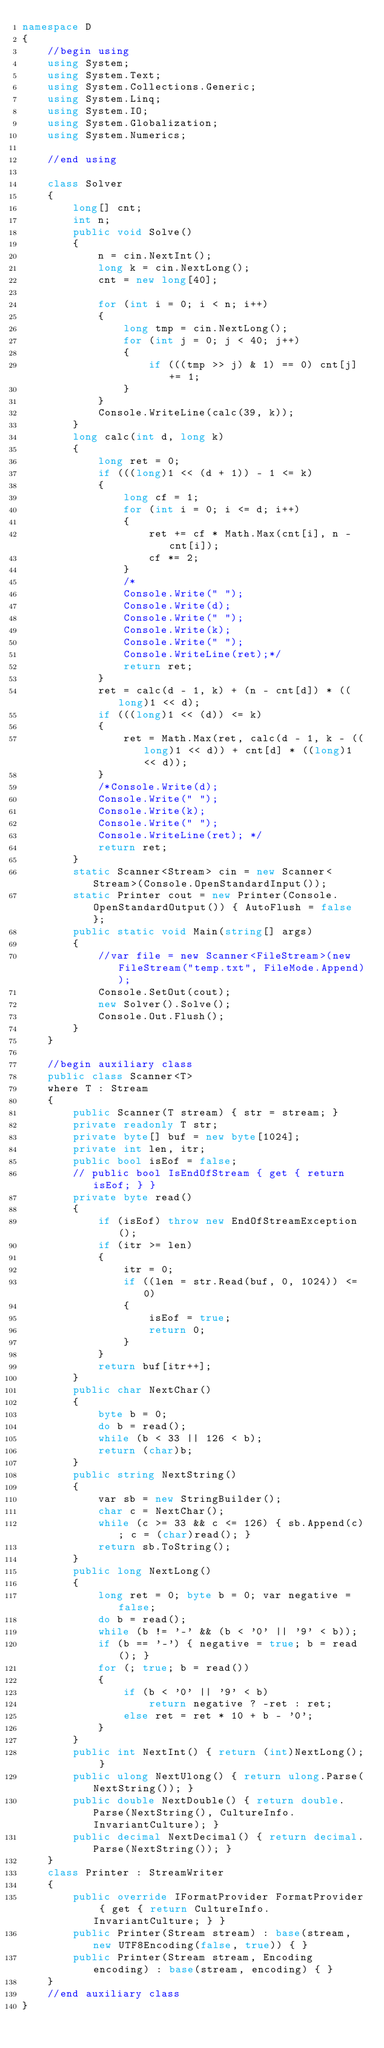<code> <loc_0><loc_0><loc_500><loc_500><_C#_>namespace D
{
    //begin using
    using System;
    using System.Text;
    using System.Collections.Generic;
    using System.Linq;
    using System.IO;
    using System.Globalization;
    using System.Numerics;

    //end using 

    class Solver
    {
        long[] cnt;
        int n;
        public void Solve()
        {
            n = cin.NextInt();
            long k = cin.NextLong();
            cnt = new long[40];

            for (int i = 0; i < n; i++)
            {
                long tmp = cin.NextLong();
                for (int j = 0; j < 40; j++)
                {
                    if (((tmp >> j) & 1) == 0) cnt[j] += 1;
                }
            }
            Console.WriteLine(calc(39, k));
        }
        long calc(int d, long k)
        {
            long ret = 0;
            if (((long)1 << (d + 1)) - 1 <= k)
            {
                long cf = 1;
                for (int i = 0; i <= d; i++)
                {
                    ret += cf * Math.Max(cnt[i], n - cnt[i]);
                    cf *= 2;
                }
                /* 
                Console.Write(" ");
                Console.Write(d);
                Console.Write(" ");
                Console.Write(k);
                Console.Write(" ");
                Console.WriteLine(ret);*/
                return ret;
            }
            ret = calc(d - 1, k) + (n - cnt[d]) * ((long)1 << d);
            if (((long)1 << (d)) <= k)
            {
                ret = Math.Max(ret, calc(d - 1, k - ((long)1 << d)) + cnt[d] * ((long)1 << d));
            }
            /*Console.Write(d);
            Console.Write(" ");
            Console.Write(k);
            Console.Write(" ");
            Console.WriteLine(ret); */
            return ret;
        }
        static Scanner<Stream> cin = new Scanner<Stream>(Console.OpenStandardInput());
        static Printer cout = new Printer(Console.OpenStandardOutput()) { AutoFlush = false };
        public static void Main(string[] args)
        {
            //var file = new Scanner<FileStream>(new FileStream("temp.txt", FileMode.Append));
            Console.SetOut(cout);
            new Solver().Solve();
            Console.Out.Flush();
        }
    }

    //begin auxiliary class
    public class Scanner<T>
    where T : Stream
    {
        public Scanner(T stream) { str = stream; }
        private readonly T str;
        private byte[] buf = new byte[1024];
        private int len, itr;
        public bool isEof = false;
        // public bool IsEndOfStream { get { return isEof; } }
        private byte read()
        {
            if (isEof) throw new EndOfStreamException();
            if (itr >= len)
            {
                itr = 0;
                if ((len = str.Read(buf, 0, 1024)) <= 0)
                {
                    isEof = true;
                    return 0;
                }
            }
            return buf[itr++];
        }
        public char NextChar()
        {
            byte b = 0;
            do b = read();
            while (b < 33 || 126 < b);
            return (char)b;
        }
        public string NextString()
        {
            var sb = new StringBuilder();
            char c = NextChar();
            while (c >= 33 && c <= 126) { sb.Append(c); c = (char)read(); }
            return sb.ToString();
        }
        public long NextLong()
        {
            long ret = 0; byte b = 0; var negative = false;
            do b = read();
            while (b != '-' && (b < '0' || '9' < b));
            if (b == '-') { negative = true; b = read(); }
            for (; true; b = read())
            {
                if (b < '0' || '9' < b)
                    return negative ? -ret : ret;
                else ret = ret * 10 + b - '0';
            }
        }
        public int NextInt() { return (int)NextLong(); }
        public ulong NextUlong() { return ulong.Parse(NextString()); }
        public double NextDouble() { return double.Parse(NextString(), CultureInfo.InvariantCulture); }
        public decimal NextDecimal() { return decimal.Parse(NextString()); }
    }
    class Printer : StreamWriter
    {
        public override IFormatProvider FormatProvider { get { return CultureInfo.InvariantCulture; } }
        public Printer(Stream stream) : base(stream, new UTF8Encoding(false, true)) { }
        public Printer(Stream stream, Encoding encoding) : base(stream, encoding) { }
    }
    //end auxiliary class
}
</code> 